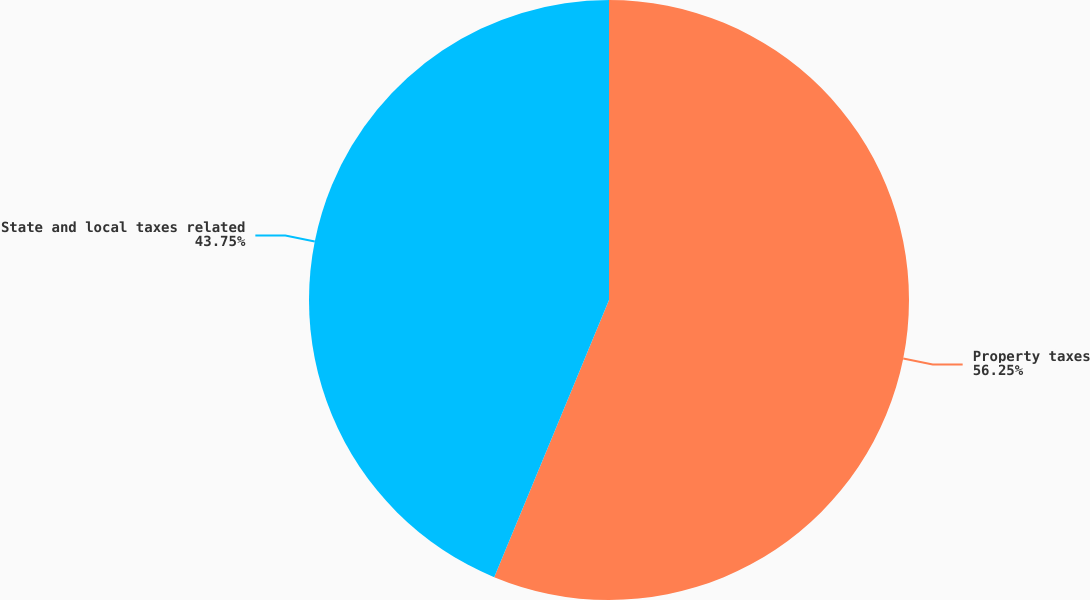Convert chart to OTSL. <chart><loc_0><loc_0><loc_500><loc_500><pie_chart><fcel>Property taxes<fcel>State and local taxes related<nl><fcel>56.25%<fcel>43.75%<nl></chart> 